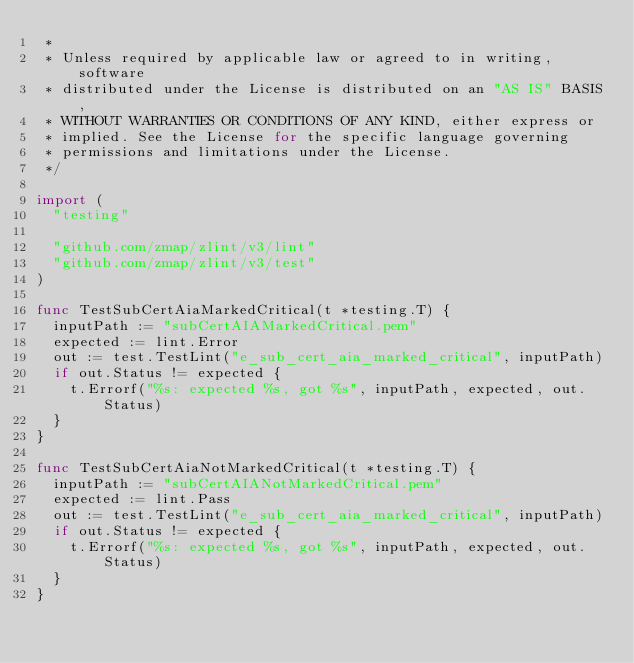Convert code to text. <code><loc_0><loc_0><loc_500><loc_500><_Go_> *
 * Unless required by applicable law or agreed to in writing, software
 * distributed under the License is distributed on an "AS IS" BASIS,
 * WITHOUT WARRANTIES OR CONDITIONS OF ANY KIND, either express or
 * implied. See the License for the specific language governing
 * permissions and limitations under the License.
 */

import (
	"testing"

	"github.com/zmap/zlint/v3/lint"
	"github.com/zmap/zlint/v3/test"
)

func TestSubCertAiaMarkedCritical(t *testing.T) {
	inputPath := "subCertAIAMarkedCritical.pem"
	expected := lint.Error
	out := test.TestLint("e_sub_cert_aia_marked_critical", inputPath)
	if out.Status != expected {
		t.Errorf("%s: expected %s, got %s", inputPath, expected, out.Status)
	}
}

func TestSubCertAiaNotMarkedCritical(t *testing.T) {
	inputPath := "subCertAIANotMarkedCritical.pem"
	expected := lint.Pass
	out := test.TestLint("e_sub_cert_aia_marked_critical", inputPath)
	if out.Status != expected {
		t.Errorf("%s: expected %s, got %s", inputPath, expected, out.Status)
	}
}
</code> 